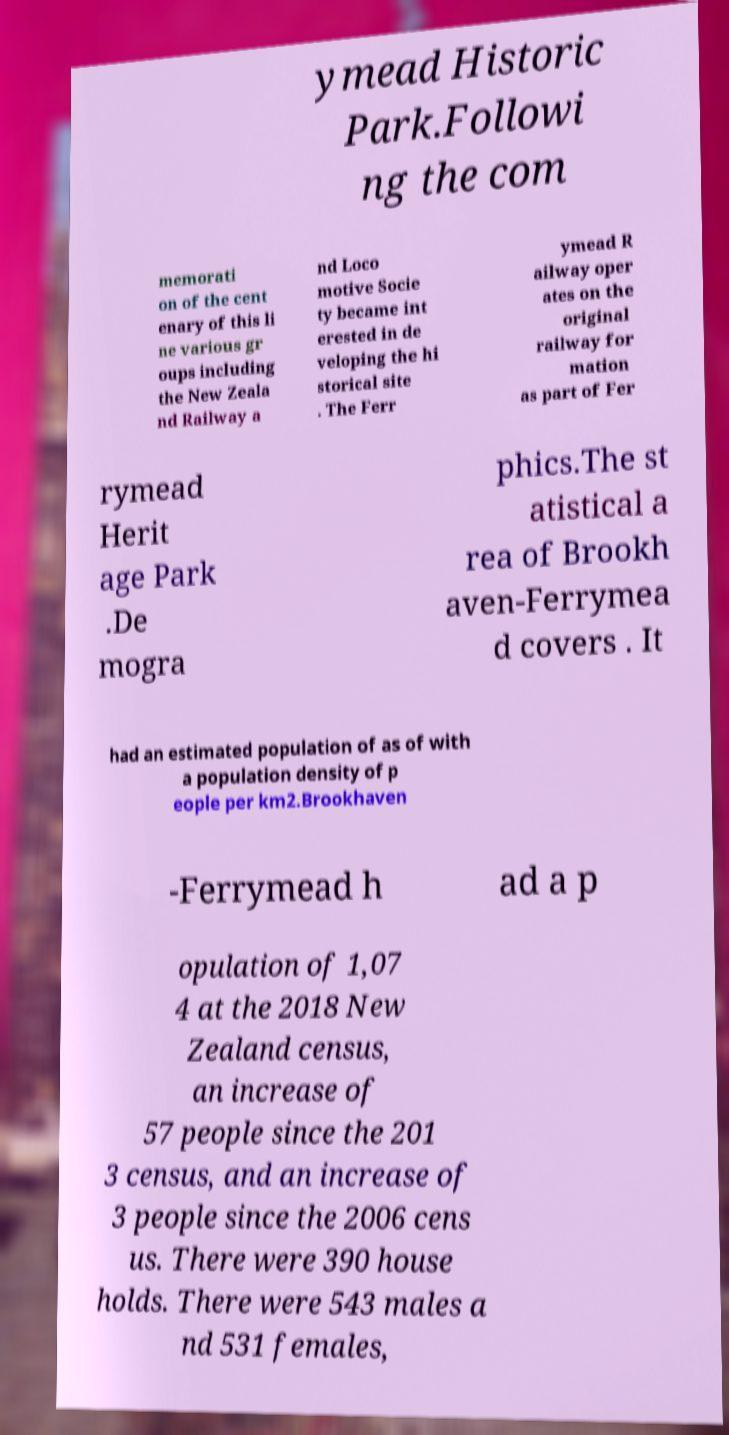For documentation purposes, I need the text within this image transcribed. Could you provide that? ymead Historic Park.Followi ng the com memorati on of the cent enary of this li ne various gr oups including the New Zeala nd Railway a nd Loco motive Socie ty became int erested in de veloping the hi storical site . The Ferr ymead R ailway oper ates on the original railway for mation as part of Fer rymead Herit age Park .De mogra phics.The st atistical a rea of Brookh aven-Ferrymea d covers . It had an estimated population of as of with a population density of p eople per km2.Brookhaven -Ferrymead h ad a p opulation of 1,07 4 at the 2018 New Zealand census, an increase of 57 people since the 201 3 census, and an increase of 3 people since the 2006 cens us. There were 390 house holds. There were 543 males a nd 531 females, 